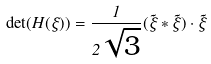<formula> <loc_0><loc_0><loc_500><loc_500>\det ( H ( \xi ) ) = \frac { 1 } { 2 \sqrt { 3 } } ( \vec { \xi } \ast \vec { \xi } ) \cdot \vec { \xi }</formula> 